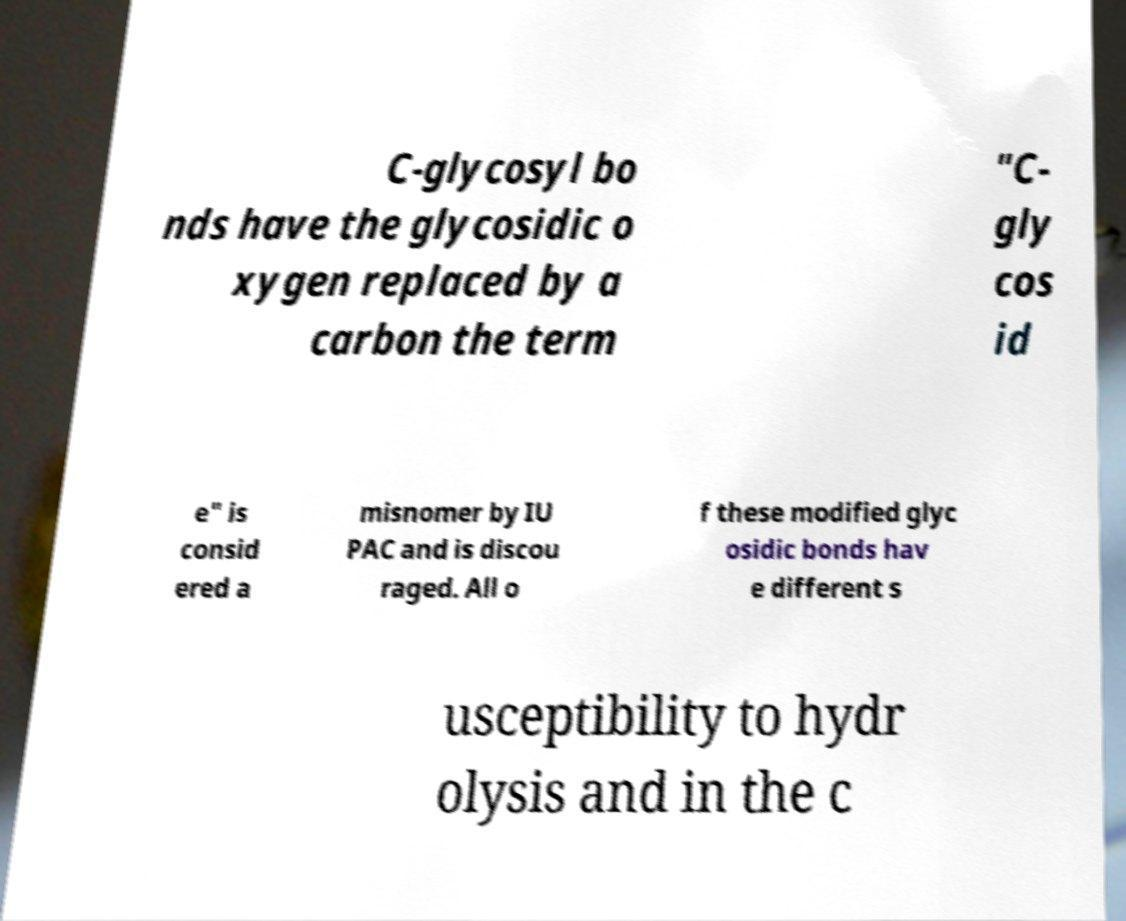Can you accurately transcribe the text from the provided image for me? C-glycosyl bo nds have the glycosidic o xygen replaced by a carbon the term "C- gly cos id e" is consid ered a misnomer by IU PAC and is discou raged. All o f these modified glyc osidic bonds hav e different s usceptibility to hydr olysis and in the c 